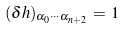Convert formula to latex. <formula><loc_0><loc_0><loc_500><loc_500>( \delta h ) _ { \alpha _ { 0 } \cdots \alpha _ { n + 2 } } \, = \, 1</formula> 